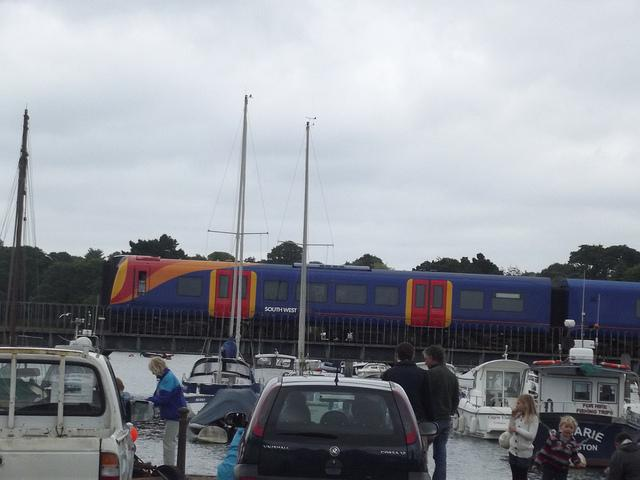Which vehicle holds the most people?

Choices:
A) boat
B) train
C) truck
D) car train 